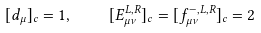<formula> <loc_0><loc_0><loc_500><loc_500>[ d _ { \mu } ] _ { c } = 1 , \quad [ E ^ { L , R } _ { \mu \nu } ] _ { c } = [ f ^ { - , L , R } _ { \mu \nu } ] _ { c } = 2</formula> 